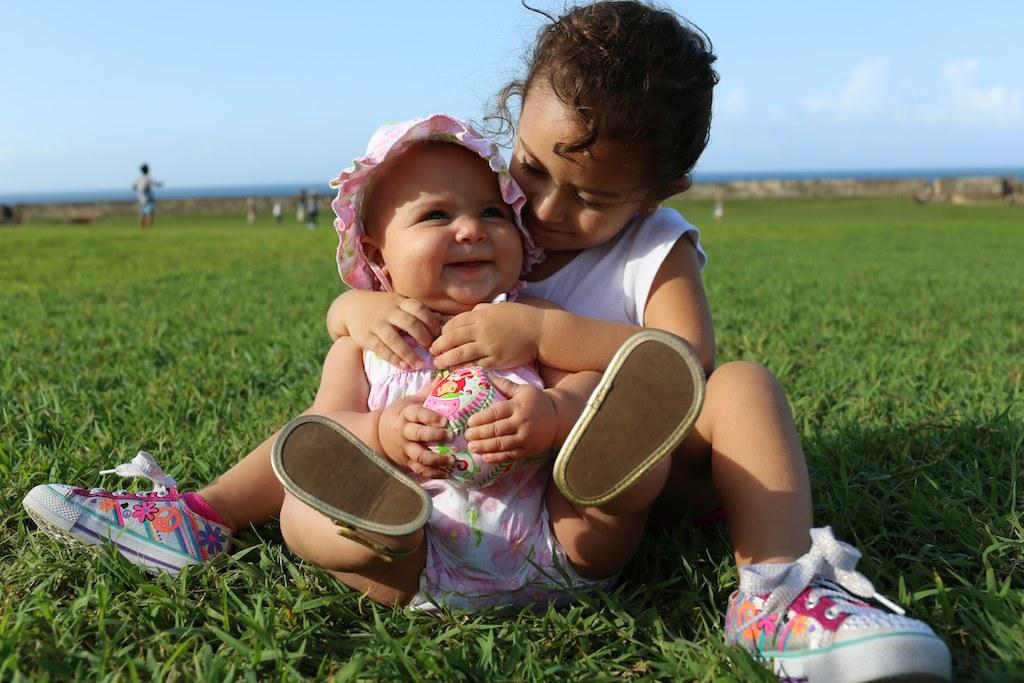How many kids are in the image? There are two kids in the image. What is the location of the kids in the image? The kids are sitting on a grassland. What can be seen in the background of the image? There are people standing in the background of the image. What is visible in the sky in the image? The sky is visible in the image. What is the opinion of the parent in the image about the current hour? There is no parent present in the image, and therefore no opinion about the current hour can be determined. 